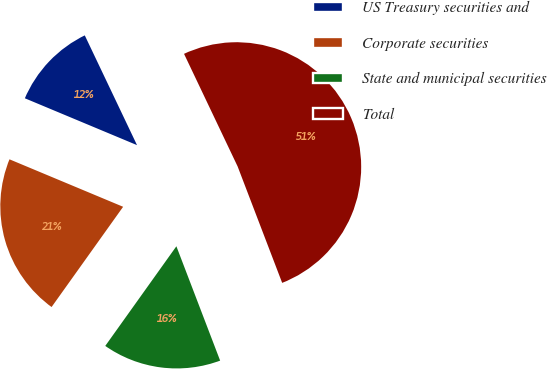Convert chart to OTSL. <chart><loc_0><loc_0><loc_500><loc_500><pie_chart><fcel>US Treasury securities and<fcel>Corporate securities<fcel>State and municipal securities<fcel>Total<nl><fcel>11.63%<fcel>21.43%<fcel>15.68%<fcel>51.25%<nl></chart> 